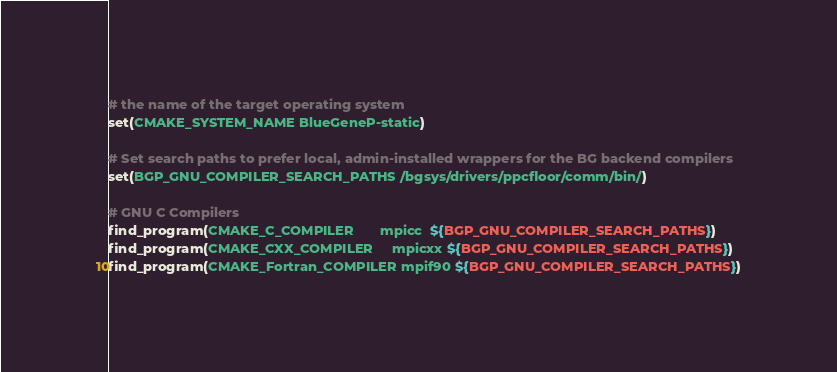Convert code to text. <code><loc_0><loc_0><loc_500><loc_500><_CMake_># the name of the target operating system
set(CMAKE_SYSTEM_NAME BlueGeneP-static)

# Set search paths to prefer local, admin-installed wrappers for the BG backend compilers
set(BGP_GNU_COMPILER_SEARCH_PATHS /bgsys/drivers/ppcfloor/comm/bin/)

# GNU C Compilers
find_program(CMAKE_C_COMPILER       mpicc  ${BGP_GNU_COMPILER_SEARCH_PATHS})
find_program(CMAKE_CXX_COMPILER     mpicxx ${BGP_GNU_COMPILER_SEARCH_PATHS})
find_program(CMAKE_Fortran_COMPILER mpif90 ${BGP_GNU_COMPILER_SEARCH_PATHS})
</code> 